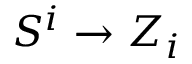Convert formula to latex. <formula><loc_0><loc_0><loc_500><loc_500>S ^ { i } \to Z _ { i }</formula> 